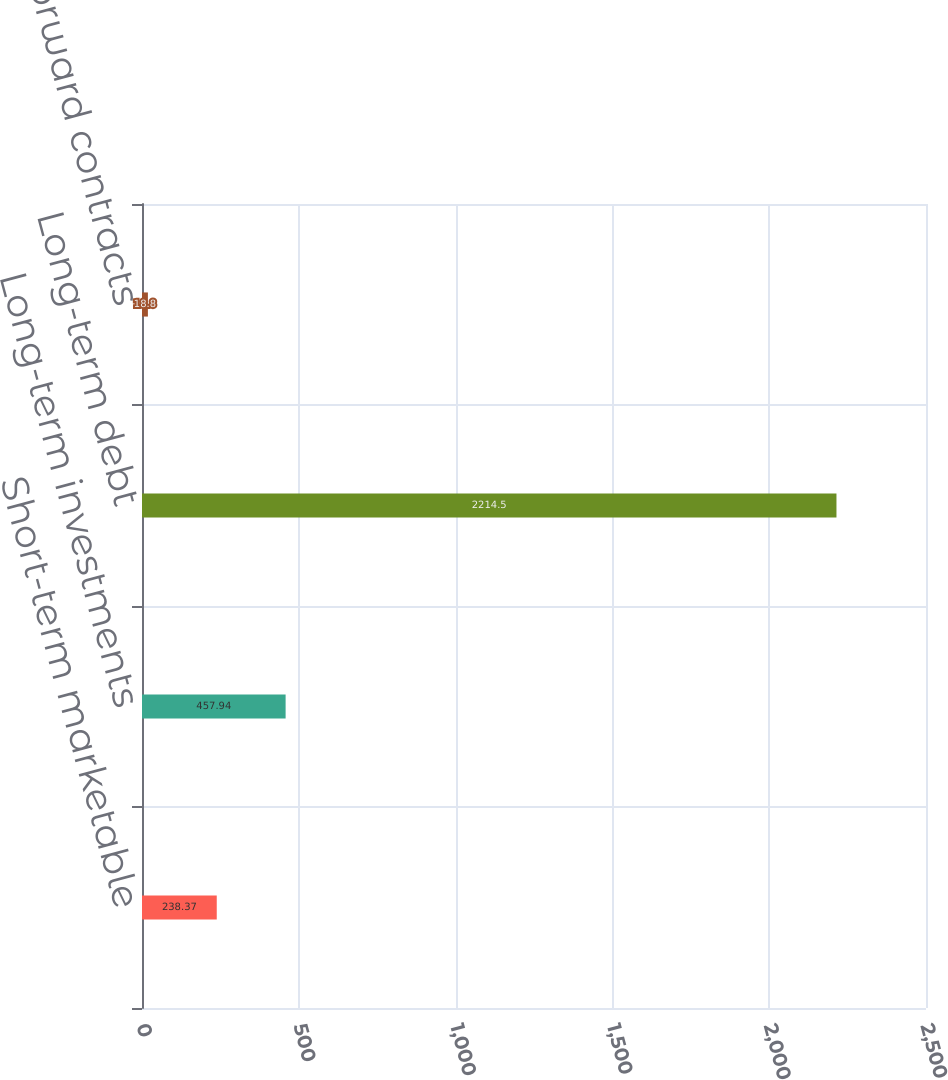<chart> <loc_0><loc_0><loc_500><loc_500><bar_chart><fcel>Short-term marketable<fcel>Long-term investments<fcel>Long-term debt<fcel>Other forward contracts<nl><fcel>238.37<fcel>457.94<fcel>2214.5<fcel>18.8<nl></chart> 